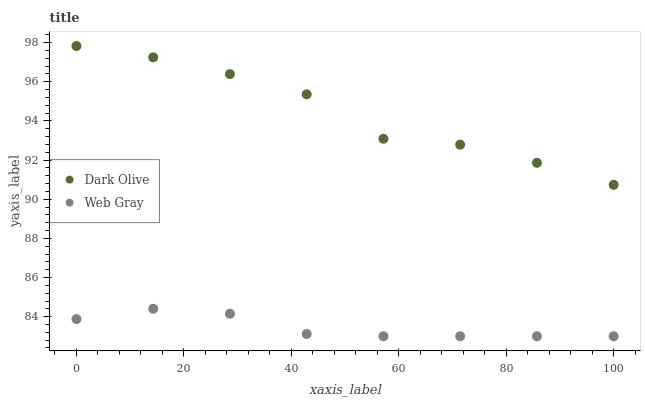Does Web Gray have the minimum area under the curve?
Answer yes or no. Yes. Does Dark Olive have the maximum area under the curve?
Answer yes or no. Yes. Does Web Gray have the maximum area under the curve?
Answer yes or no. No. Is Web Gray the smoothest?
Answer yes or no. Yes. Is Dark Olive the roughest?
Answer yes or no. Yes. Is Web Gray the roughest?
Answer yes or no. No. Does Web Gray have the lowest value?
Answer yes or no. Yes. Does Dark Olive have the highest value?
Answer yes or no. Yes. Does Web Gray have the highest value?
Answer yes or no. No. Is Web Gray less than Dark Olive?
Answer yes or no. Yes. Is Dark Olive greater than Web Gray?
Answer yes or no. Yes. Does Web Gray intersect Dark Olive?
Answer yes or no. No. 